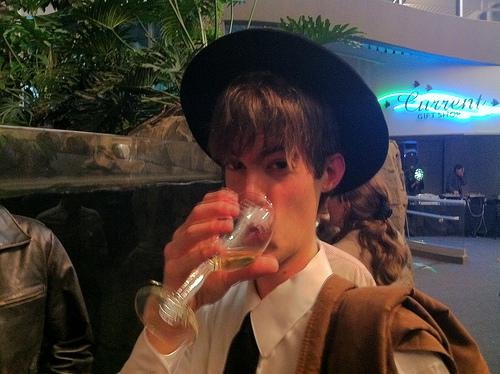Question: when was the picture taken?
Choices:
A. At a wedding.
B. During a party.
C. During a celebration.
D. Graduation.
Answer with the letter. Answer: B Question: why is the boys drinking from the glass?
Choices:
A. He likes grape juice.
B. He is hot.
C. He wants water.
D. He's thirsty.
Answer with the letter. Answer: D Question: what color is the boy's hair?
Choices:
A. Blonde.
B. Brown.
C. Black.
D. Light grey.
Answer with the letter. Answer: B Question: who is drinking from the glass?
Choices:
A. A man.
B. A boy.
C. A lady.
D. A girl.
Answer with the letter. Answer: B 